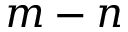<formula> <loc_0><loc_0><loc_500><loc_500>m - n</formula> 